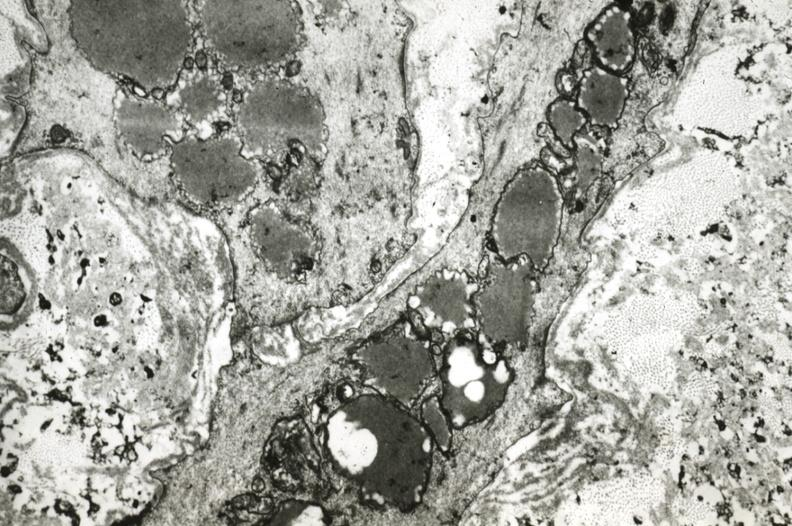where is this?
Answer the question using a single word or phrase. Vasculature 